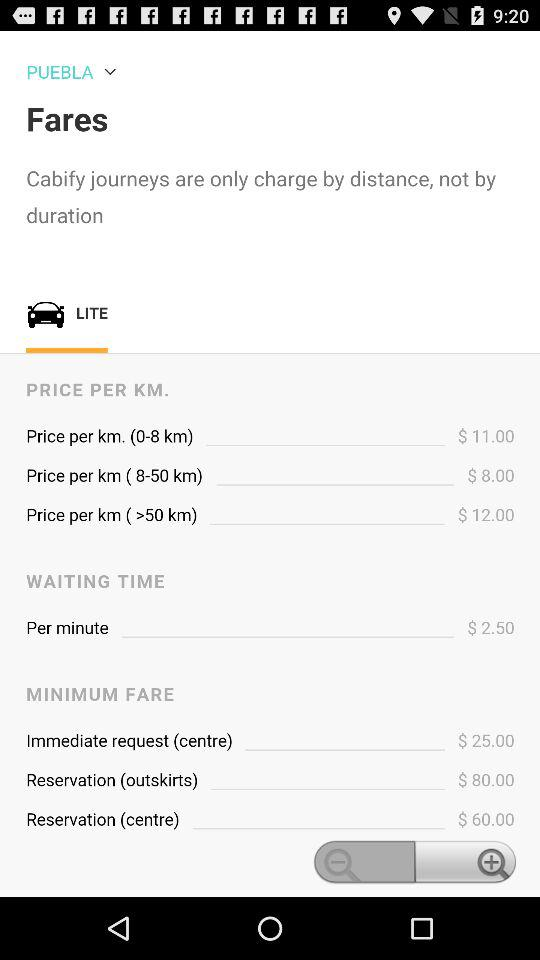By what parameter does "Cabify" charge for a journey? "Cabify" charges for a journey by distance. 